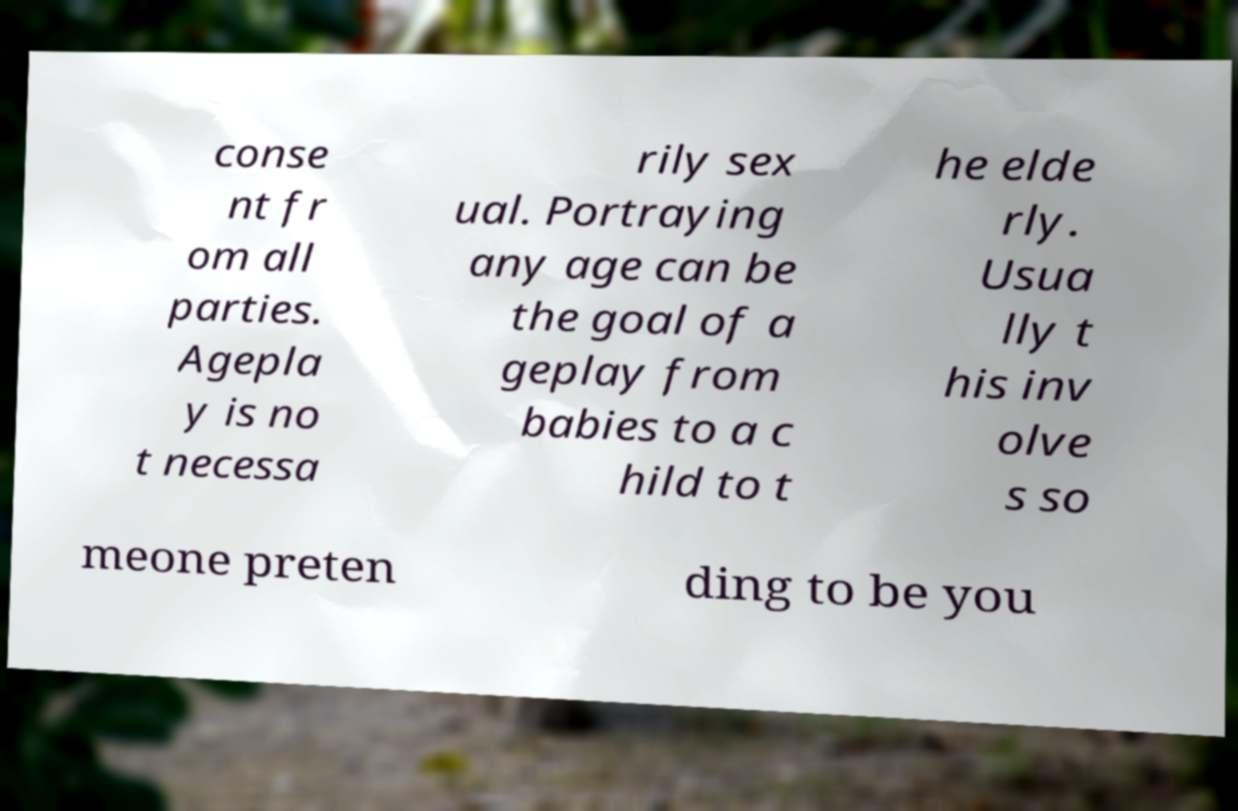I need the written content from this picture converted into text. Can you do that? conse nt fr om all parties. Agepla y is no t necessa rily sex ual. Portraying any age can be the goal of a geplay from babies to a c hild to t he elde rly. Usua lly t his inv olve s so meone preten ding to be you 